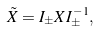Convert formula to latex. <formula><loc_0><loc_0><loc_500><loc_500>\tilde { X } = I _ { \pm } X I ^ { - 1 } _ { \pm } ,</formula> 